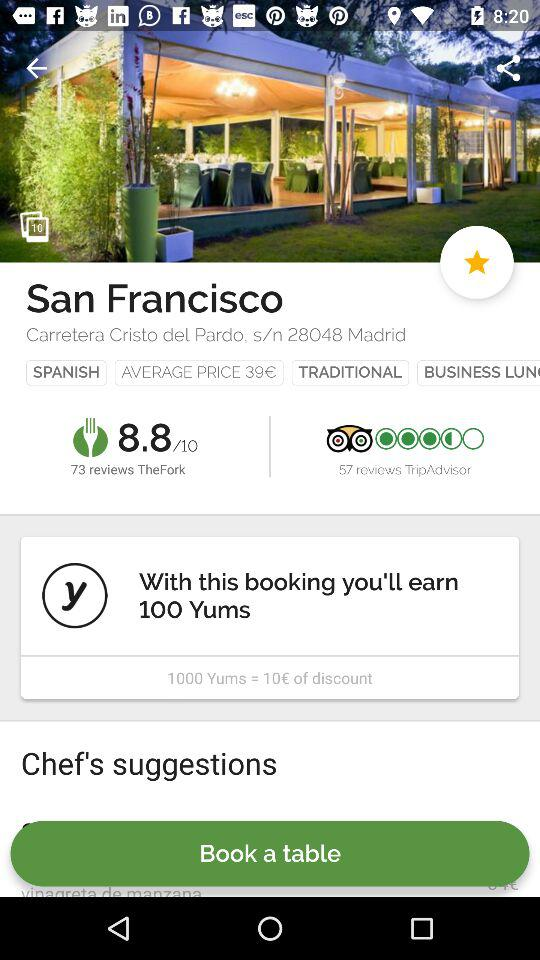How do I reserve a table?
When the provided information is insufficient, respond with <no answer>. <no answer> 